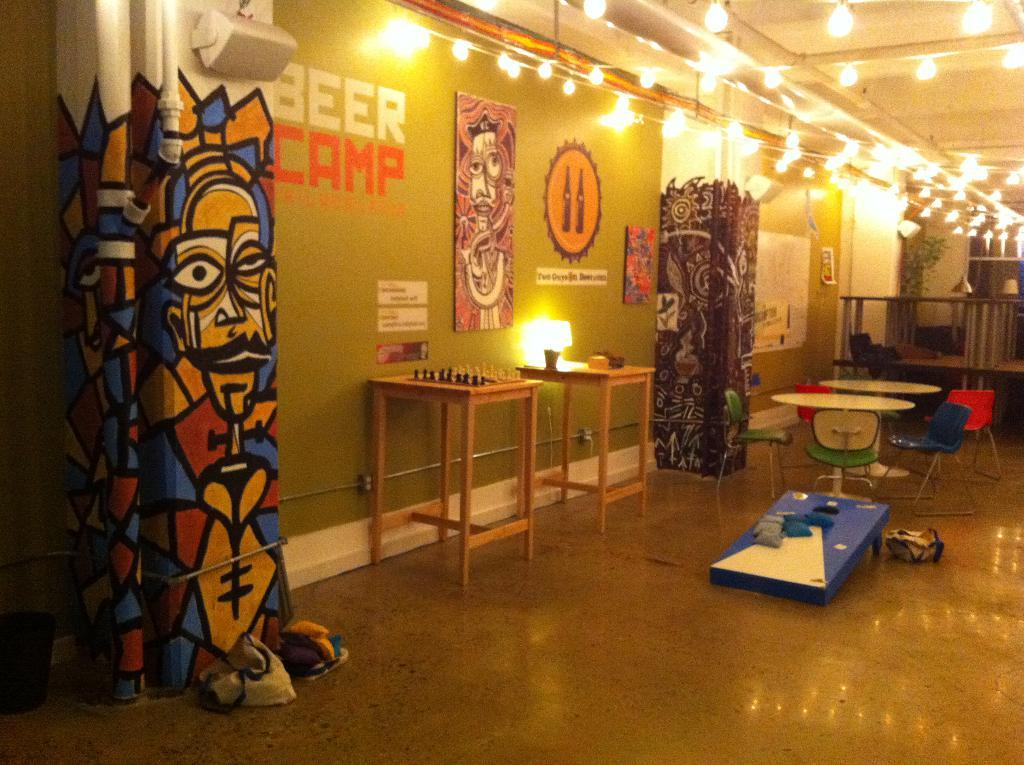<image>
Relay a brief, clear account of the picture shown. a room with BEER CAMP written on the wall with chess, table and chairs and a bean bag toss game. 